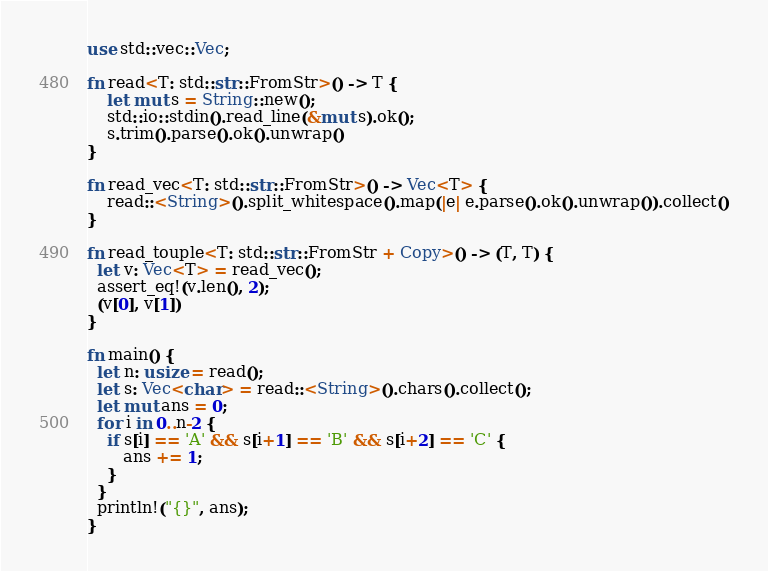Convert code to text. <code><loc_0><loc_0><loc_500><loc_500><_Rust_>use std::vec::Vec;

fn read<T: std::str::FromStr>() -> T {
    let mut s = String::new();
    std::io::stdin().read_line(&mut s).ok();
    s.trim().parse().ok().unwrap()
}

fn read_vec<T: std::str::FromStr>() -> Vec<T> {
    read::<String>().split_whitespace().map(|e| e.parse().ok().unwrap()).collect()
}

fn read_touple<T: std::str::FromStr + Copy>() -> (T, T) {
  let v: Vec<T> = read_vec();
  assert_eq!(v.len(), 2);
  (v[0], v[1])
}

fn main() {
  let n: usize = read();
  let s: Vec<char> = read::<String>().chars().collect();
  let mut ans = 0;
  for i in 0..n-2 {
    if s[i] == 'A' && s[i+1] == 'B' && s[i+2] == 'C' {
       ans += 1;
    }
  }
  println!("{}", ans);
}
</code> 